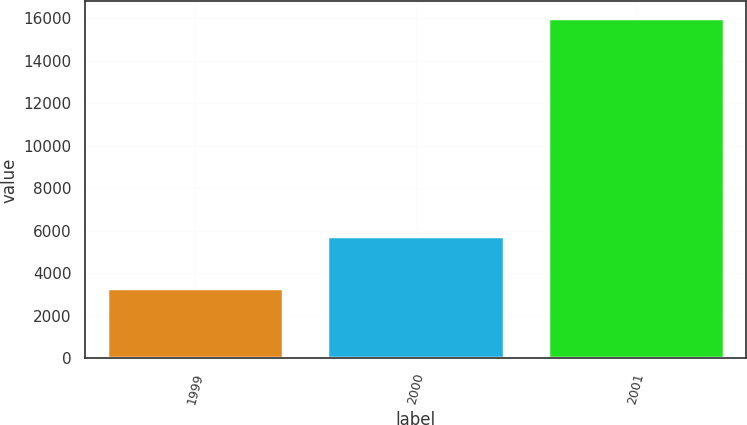Convert chart to OTSL. <chart><loc_0><loc_0><loc_500><loc_500><bar_chart><fcel>1999<fcel>2000<fcel>2001<nl><fcel>3316<fcel>5740<fcel>15989<nl></chart> 